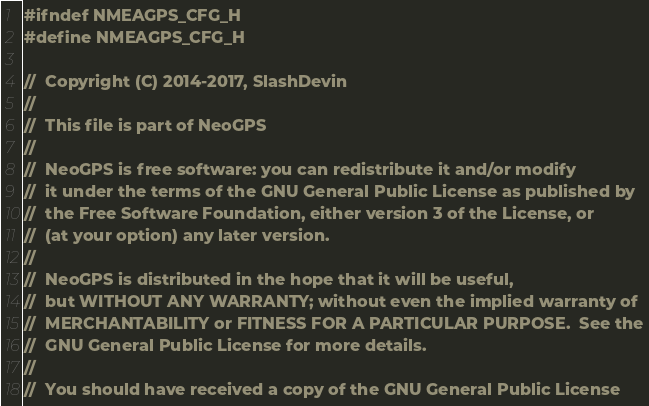<code> <loc_0><loc_0><loc_500><loc_500><_C_>#ifndef NMEAGPS_CFG_H
#define NMEAGPS_CFG_H

//  Copyright (C) 2014-2017, SlashDevin
//
//  This file is part of NeoGPS
//
//  NeoGPS is free software: you can redistribute it and/or modify
//  it under the terms of the GNU General Public License as published by
//  the Free Software Foundation, either version 3 of the License, or
//  (at your option) any later version.
//
//  NeoGPS is distributed in the hope that it will be useful,
//  but WITHOUT ANY WARRANTY; without even the implied warranty of
//  MERCHANTABILITY or FITNESS FOR A PARTICULAR PURPOSE.  See the
//  GNU General Public License for more details.
//
//  You should have received a copy of the GNU General Public License</code> 